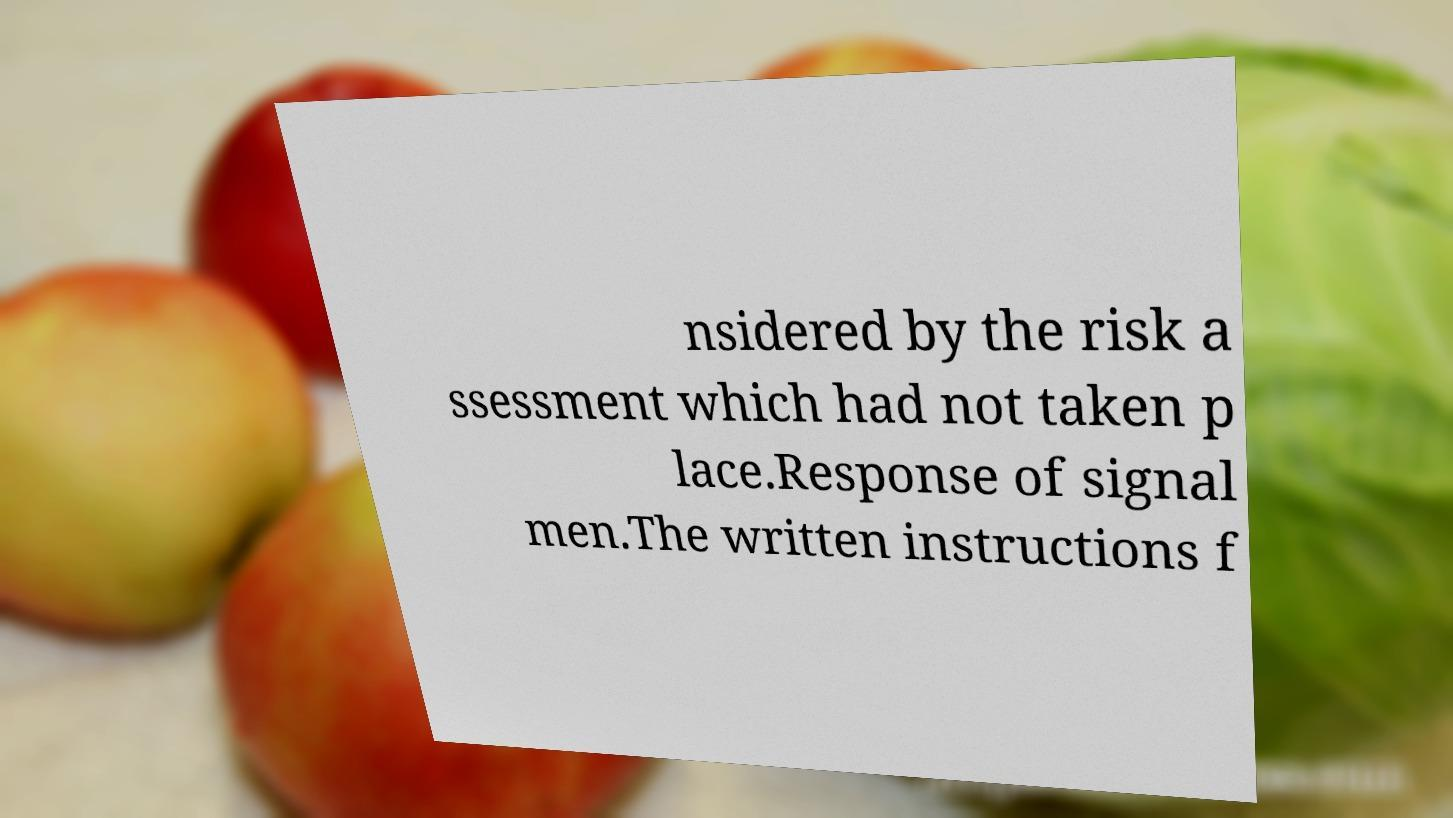Can you accurately transcribe the text from the provided image for me? nsidered by the risk a ssessment which had not taken p lace.Response of signal men.The written instructions f 